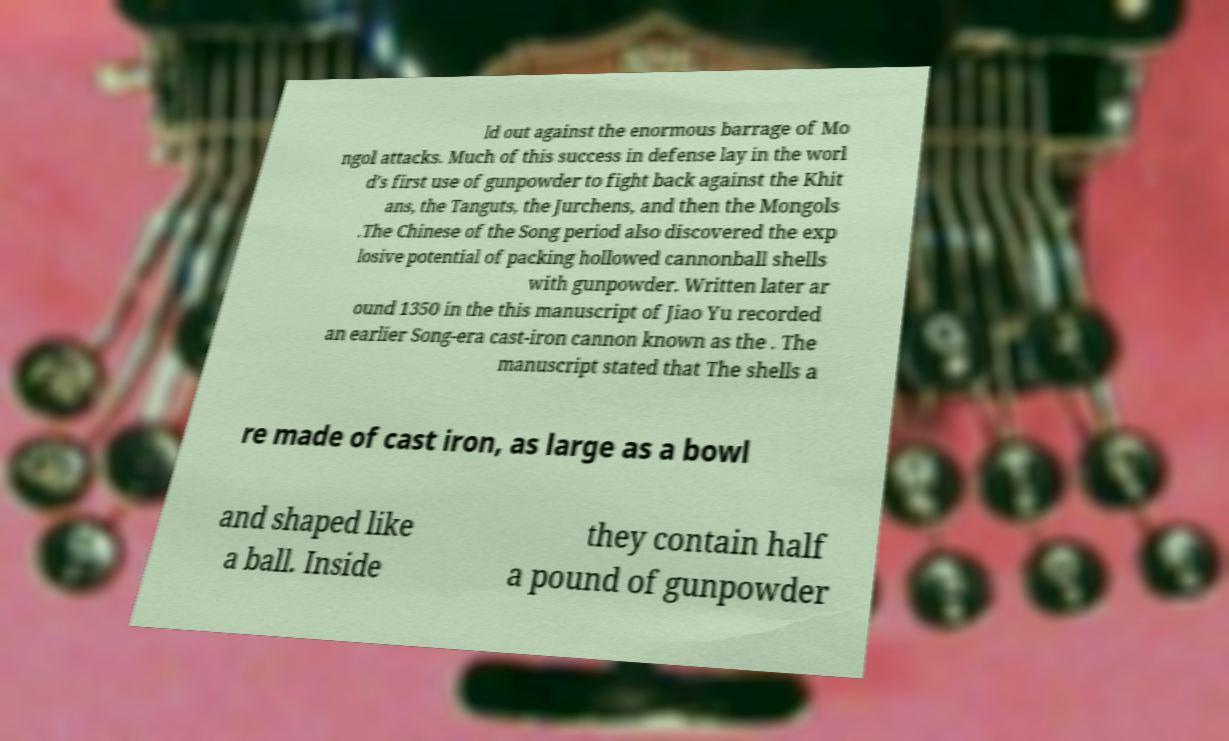I need the written content from this picture converted into text. Can you do that? ld out against the enormous barrage of Mo ngol attacks. Much of this success in defense lay in the worl d's first use of gunpowder to fight back against the Khit ans, the Tanguts, the Jurchens, and then the Mongols .The Chinese of the Song period also discovered the exp losive potential of packing hollowed cannonball shells with gunpowder. Written later ar ound 1350 in the this manuscript of Jiao Yu recorded an earlier Song-era cast-iron cannon known as the . The manuscript stated that The shells a re made of cast iron, as large as a bowl and shaped like a ball. Inside they contain half a pound of gunpowder 